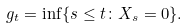<formula> <loc_0><loc_0><loc_500><loc_500>g _ { t } = \inf \{ s \leq t \colon X _ { s } = 0 \} .</formula> 